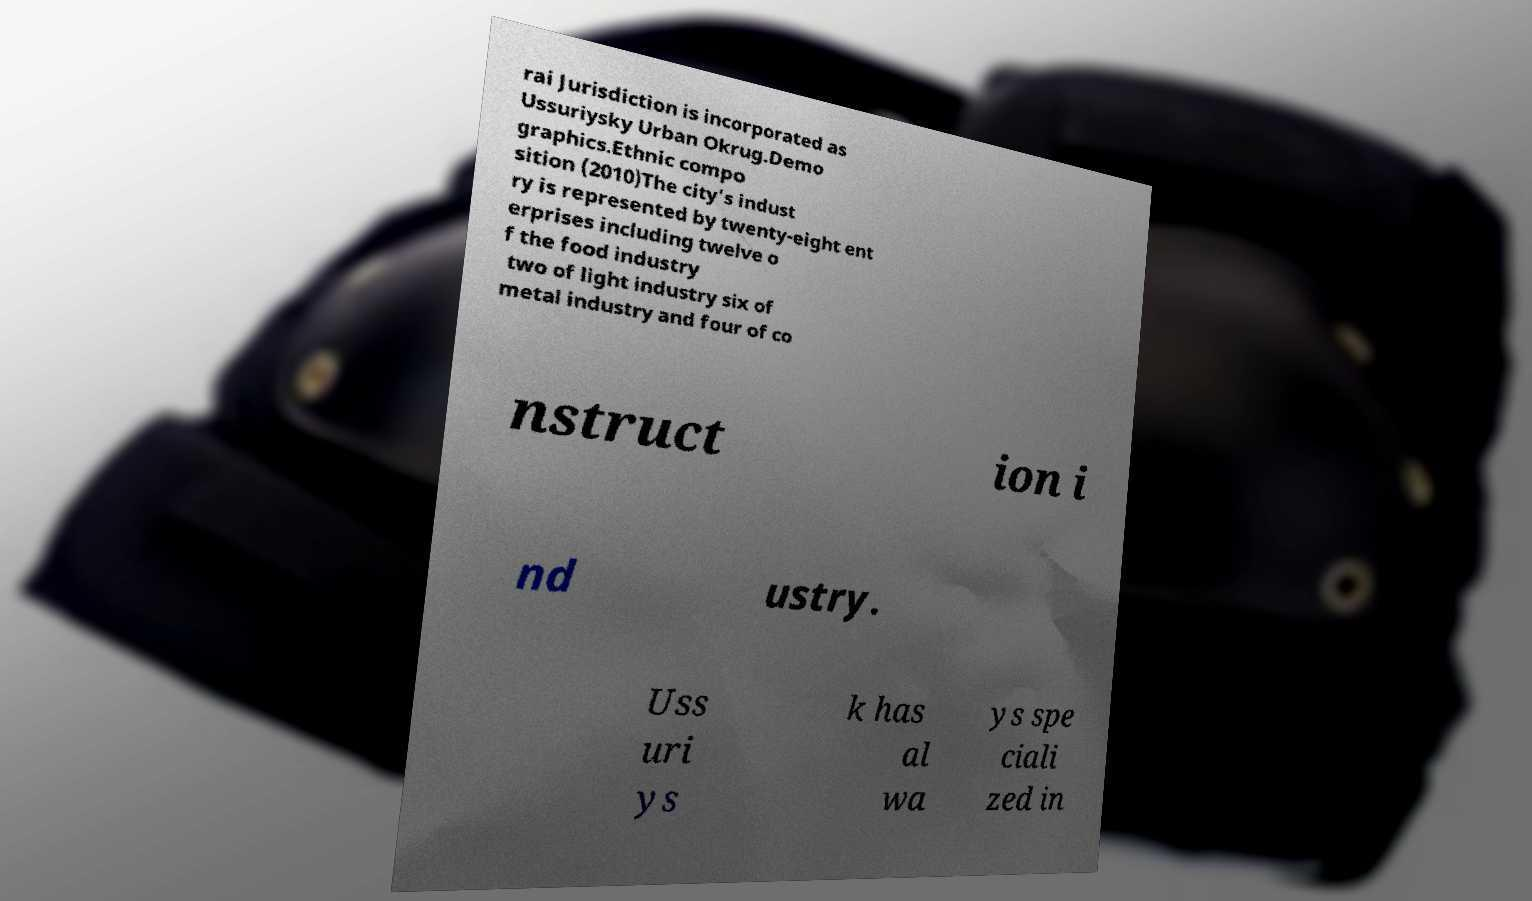Can you accurately transcribe the text from the provided image for me? rai Jurisdiction is incorporated as Ussuriysky Urban Okrug.Demo graphics.Ethnic compo sition (2010)The city's indust ry is represented by twenty-eight ent erprises including twelve o f the food industry two of light industry six of metal industry and four of co nstruct ion i nd ustry. Uss uri ys k has al wa ys spe ciali zed in 